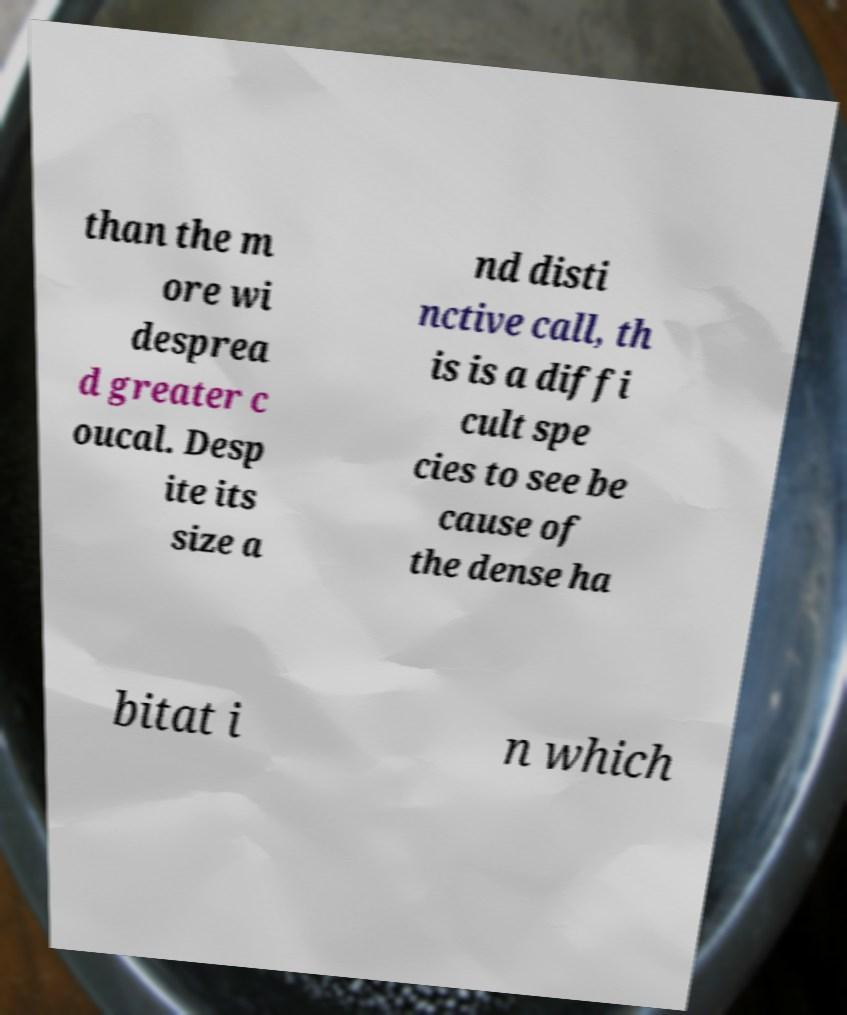Can you accurately transcribe the text from the provided image for me? than the m ore wi desprea d greater c oucal. Desp ite its size a nd disti nctive call, th is is a diffi cult spe cies to see be cause of the dense ha bitat i n which 